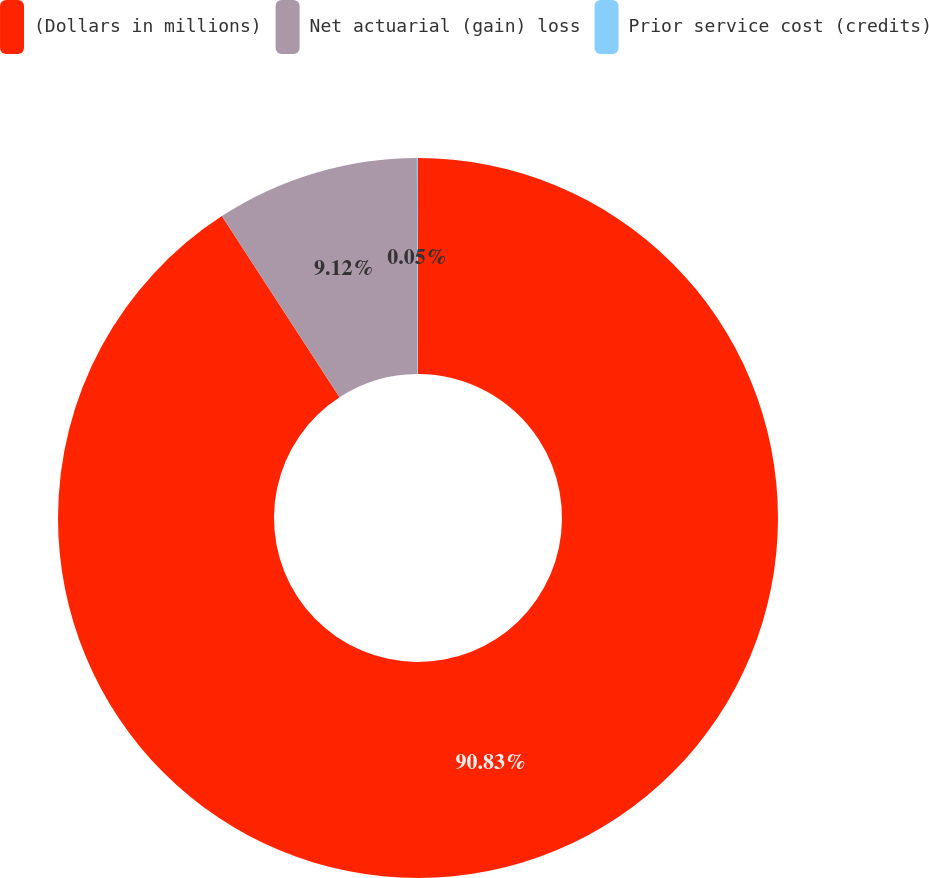Convert chart to OTSL. <chart><loc_0><loc_0><loc_500><loc_500><pie_chart><fcel>(Dollars in millions)<fcel>Net actuarial (gain) loss<fcel>Prior service cost (credits)<nl><fcel>90.83%<fcel>9.12%<fcel>0.05%<nl></chart> 